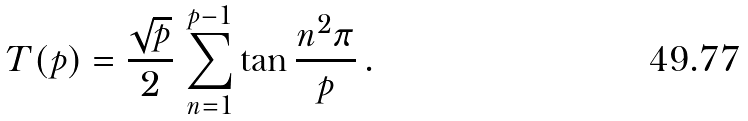Convert formula to latex. <formula><loc_0><loc_0><loc_500><loc_500>T ( p ) = \frac { \sqrt { p } } { 2 } \, \sum _ { n = 1 } ^ { p - 1 } \tan \frac { n ^ { 2 } \pi } { p } \, .</formula> 